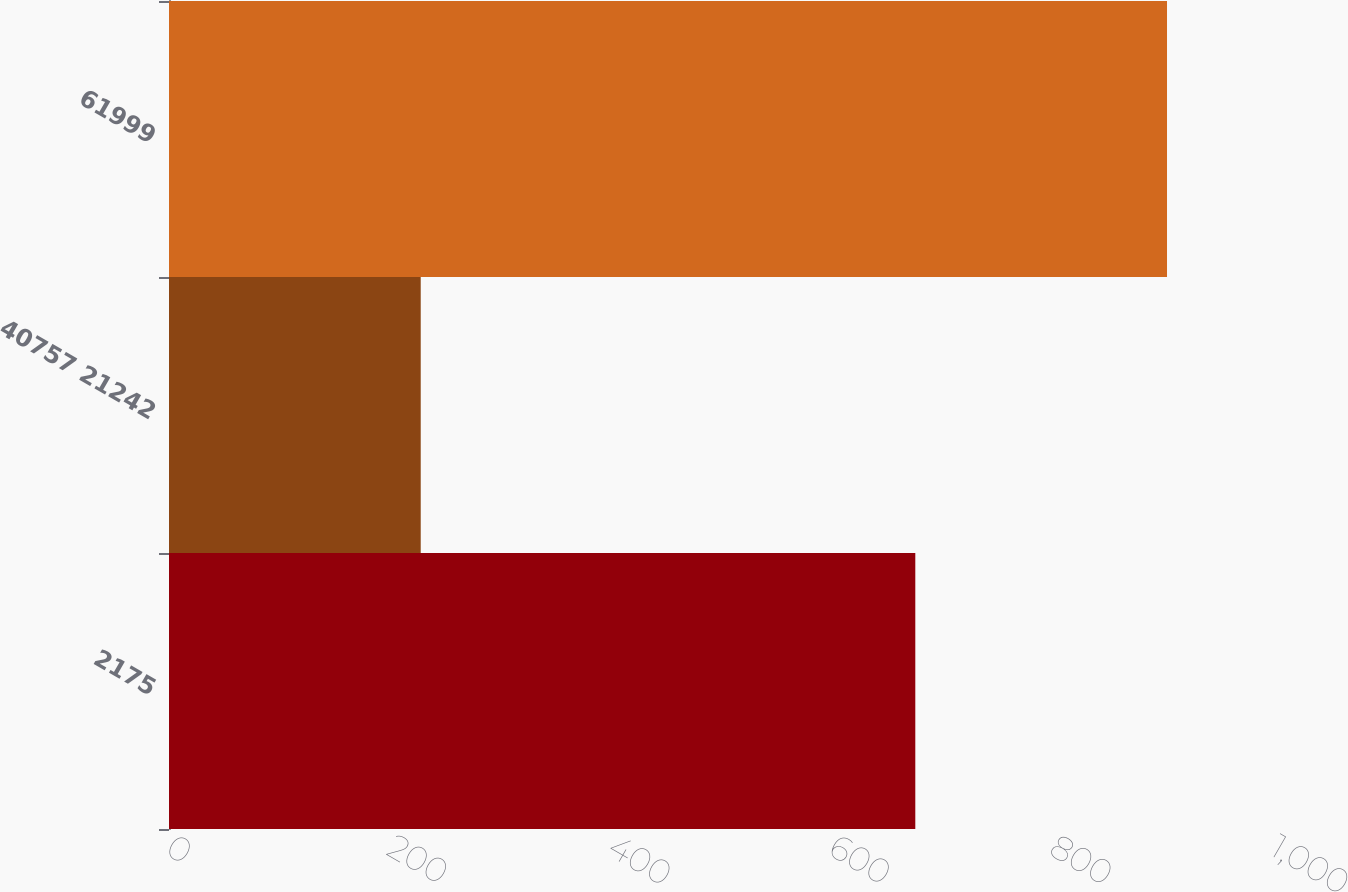<chart> <loc_0><loc_0><loc_500><loc_500><bar_chart><fcel>2175<fcel>40757 21242<fcel>61999<nl><fcel>676<fcel>228<fcel>904<nl></chart> 